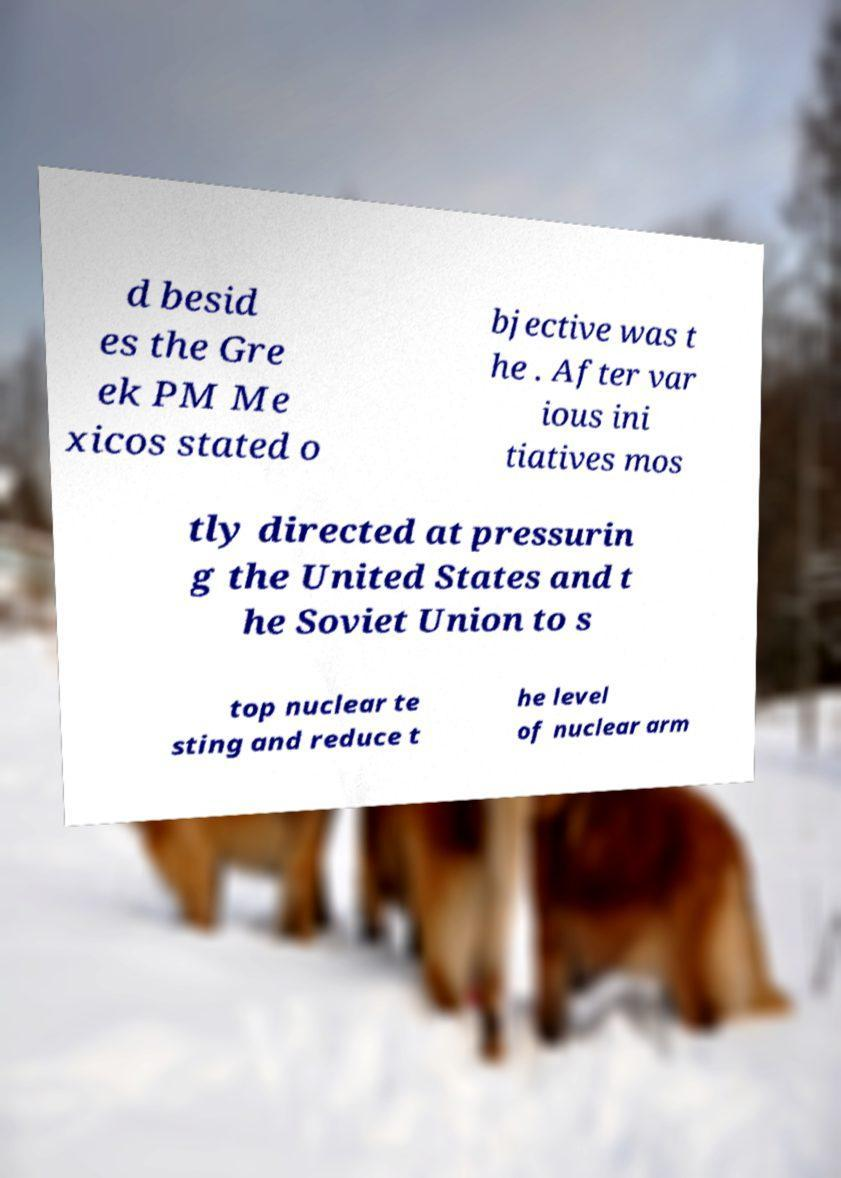Could you assist in decoding the text presented in this image and type it out clearly? d besid es the Gre ek PM Me xicos stated o bjective was t he . After var ious ini tiatives mos tly directed at pressurin g the United States and t he Soviet Union to s top nuclear te sting and reduce t he level of nuclear arm 